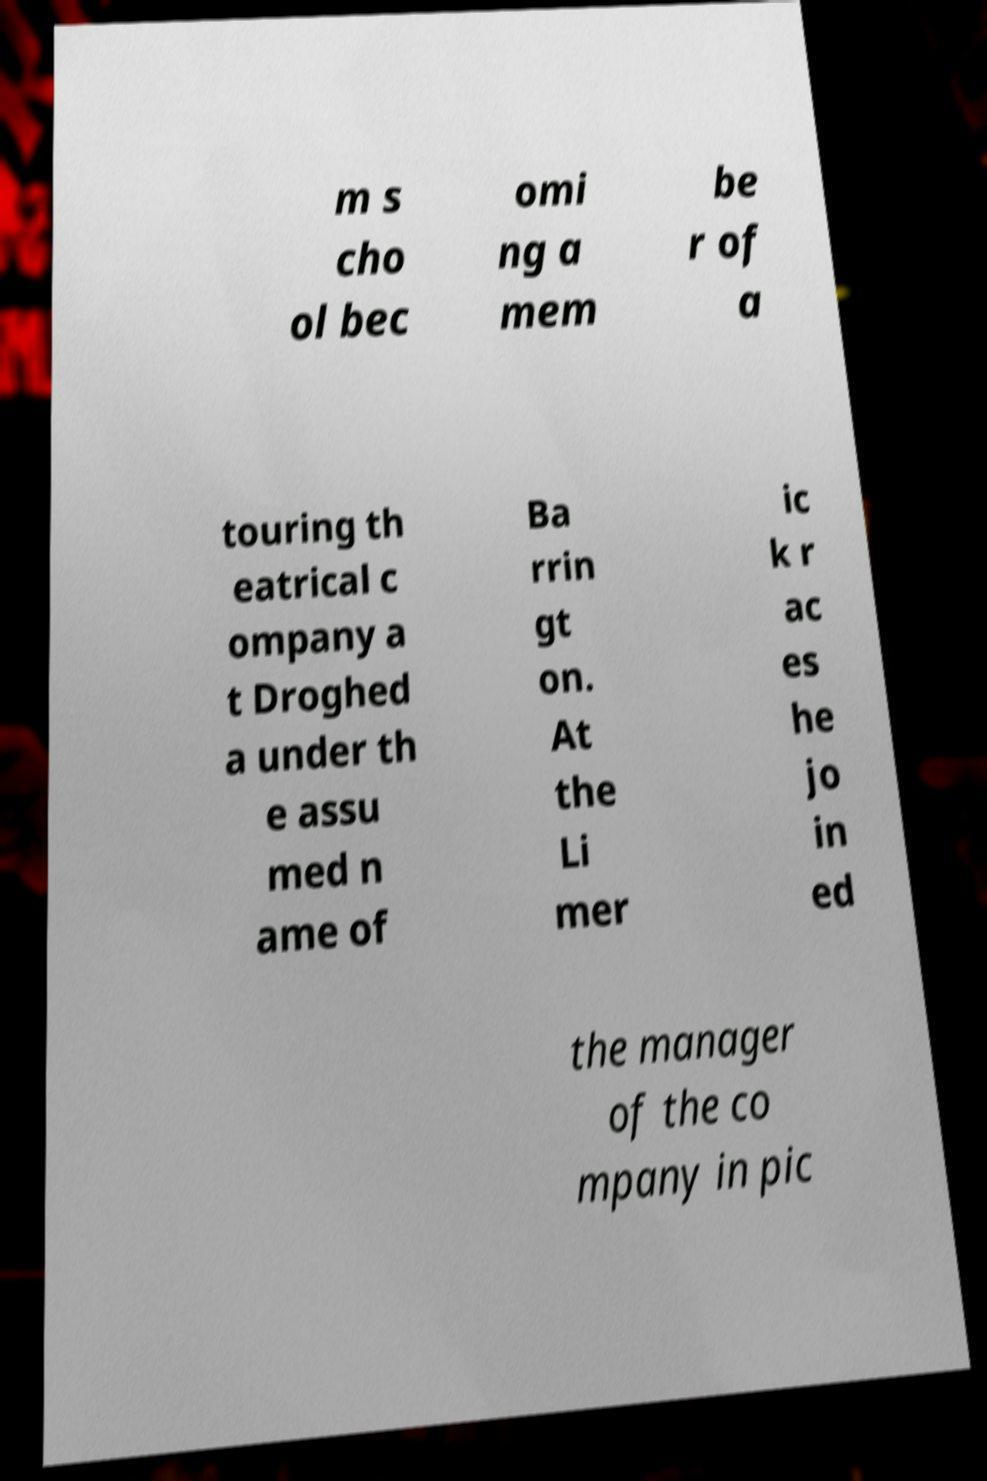What messages or text are displayed in this image? I need them in a readable, typed format. m s cho ol bec omi ng a mem be r of a touring th eatrical c ompany a t Droghed a under th e assu med n ame of Ba rrin gt on. At the Li mer ic k r ac es he jo in ed the manager of the co mpany in pic 